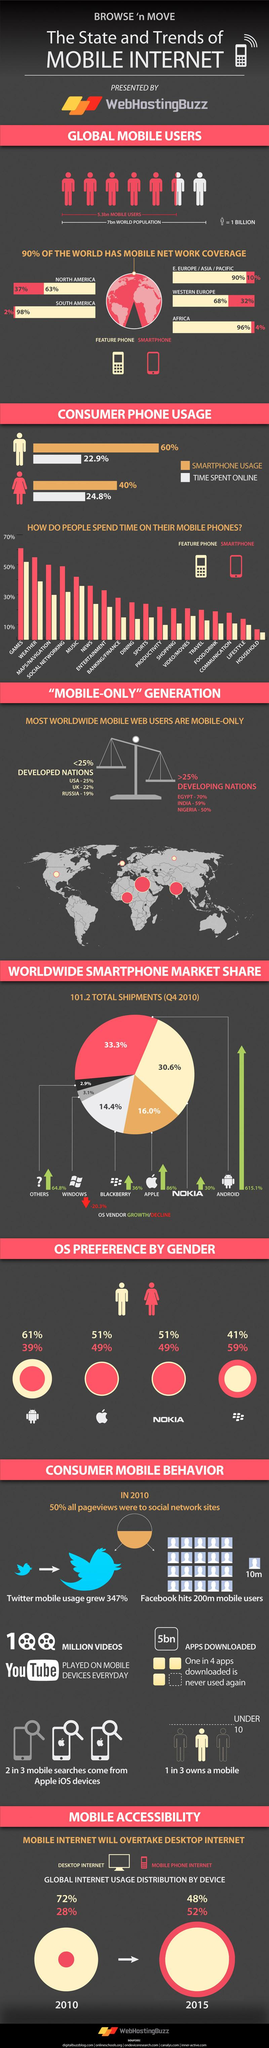Outline some significant characteristics in this image. Smartphone users typically spend more than 40% of their time using their phones for music activities. Females spend more time online compared to males, according to research. Among feature phone users, productivity is the activity that has the second lowest percentage, with the exception of entertainment. In North America, it is common for individuals to use feature phones as their primary device. According to the data, North America has the highest number of smartphone users among the continents of Western Europe, Eastern Europe, and North America. 